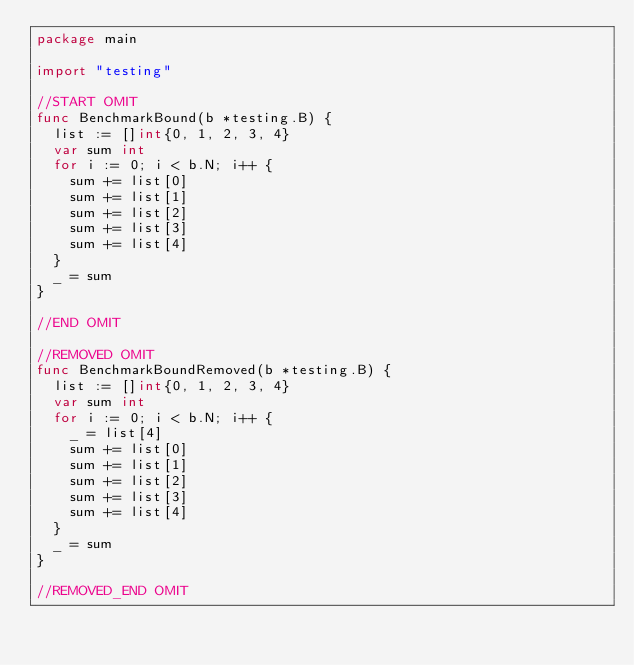Convert code to text. <code><loc_0><loc_0><loc_500><loc_500><_Go_>package main

import "testing"

//START OMIT
func BenchmarkBound(b *testing.B) {
	list := []int{0, 1, 2, 3, 4}
	var sum int
	for i := 0; i < b.N; i++ {
		sum += list[0]
		sum += list[1]
		sum += list[2]
		sum += list[3]
		sum += list[4]
	}
	_ = sum
}

//END OMIT

//REMOVED OMIT
func BenchmarkBoundRemoved(b *testing.B) {
	list := []int{0, 1, 2, 3, 4}
	var sum int
	for i := 0; i < b.N; i++ {
		_ = list[4]
		sum += list[0]
		sum += list[1]
		sum += list[2]
		sum += list[3]
		sum += list[4]
	}
	_ = sum
}

//REMOVED_END OMIT
</code> 